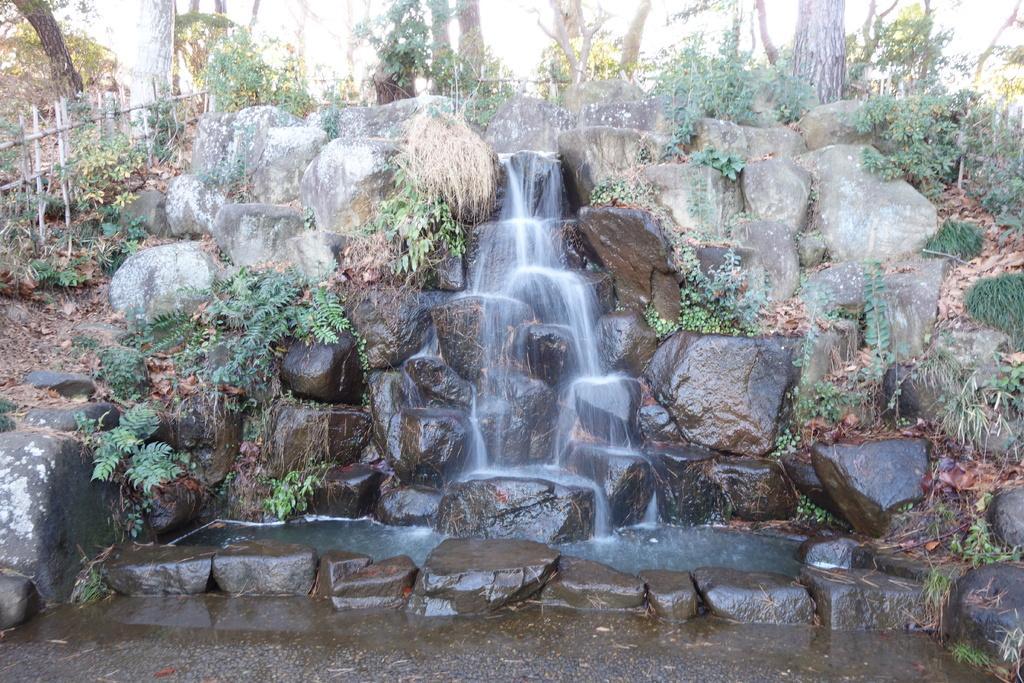How would you summarize this image in a sentence or two? This picture might be taken from outside of the city. In this image, on the right side, we can see some plants and trees. On the left side, we can also see some stick grills, trees. In the middle of the image, we can see a water flowing on the stones and some plants. 